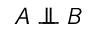Convert formula to latex. <formula><loc_0><loc_0><loc_500><loc_500>A \perp \, \perp B</formula> 